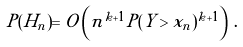<formula> <loc_0><loc_0><loc_500><loc_500>P ( H _ { n } ) = O \left ( n ^ { k + 1 } P ( Y > x _ { n } ) ^ { k + 1 } \right ) \, .</formula> 